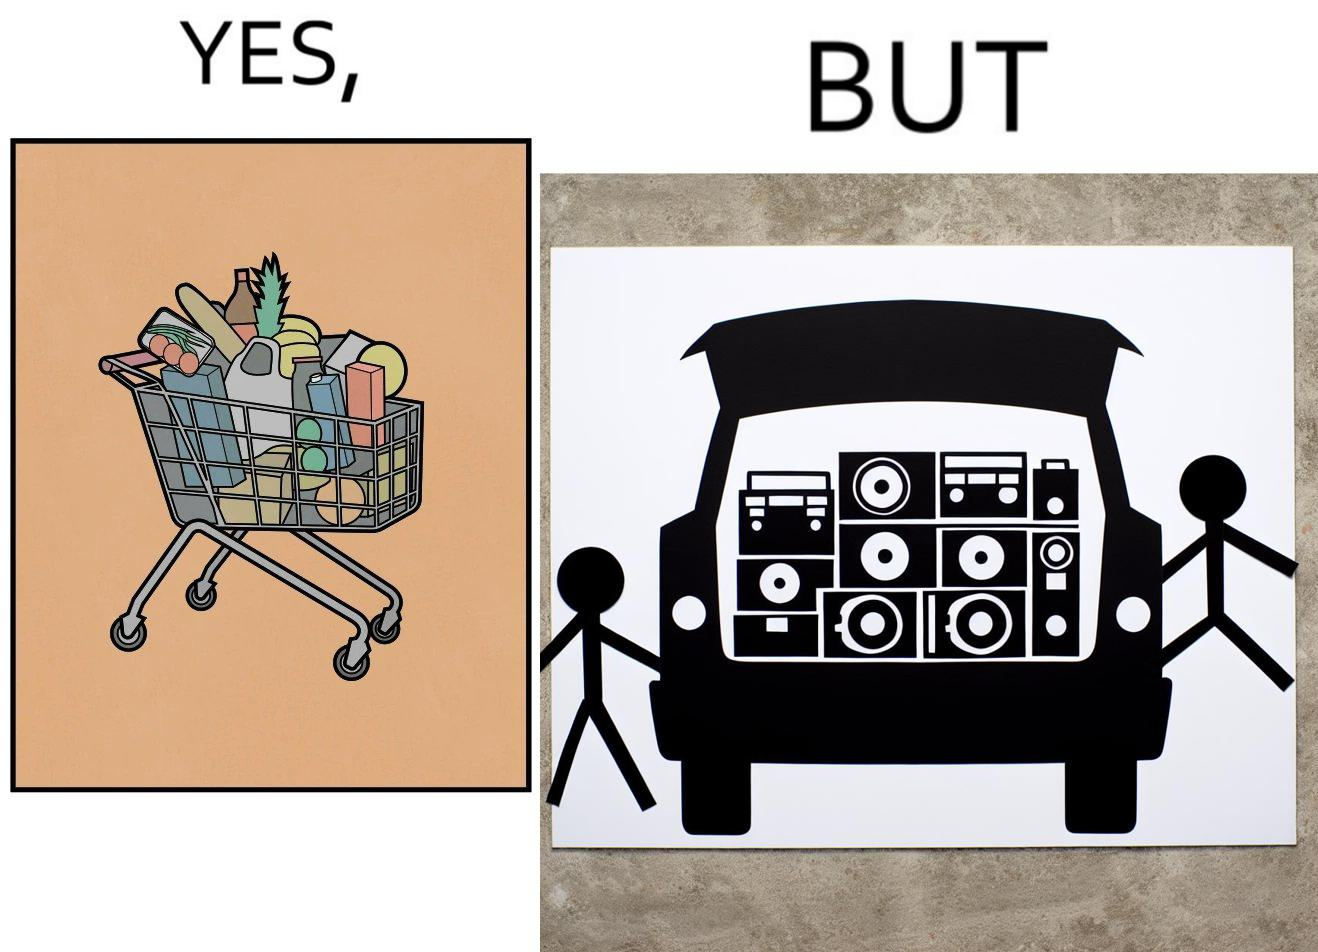Is this a satirical image? Yes, this image is satirical. 